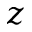<formula> <loc_0><loc_0><loc_500><loc_500>z</formula> 